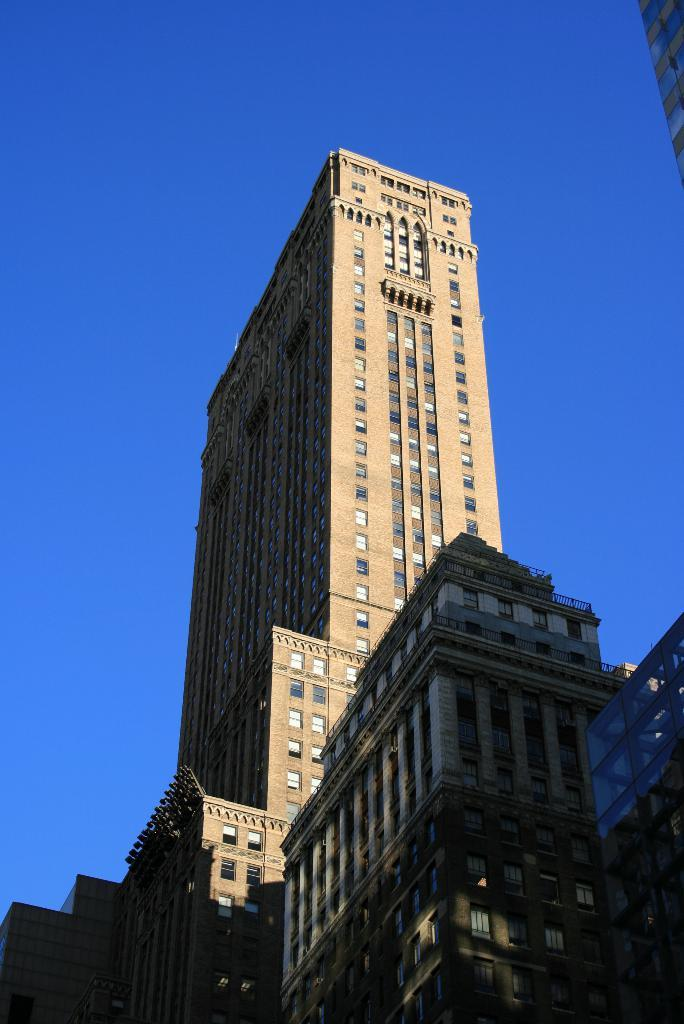What type of structures are present in the image? There are very big buildings in the image. What is visible at the top of the image? The sky is visible at the top of the image. How many kittens are holding the yoke in the image? There are no kittens or yokes present in the image. What type of currency is being exchanged in the image? There is no exchange of money or currency depicted in the image. 